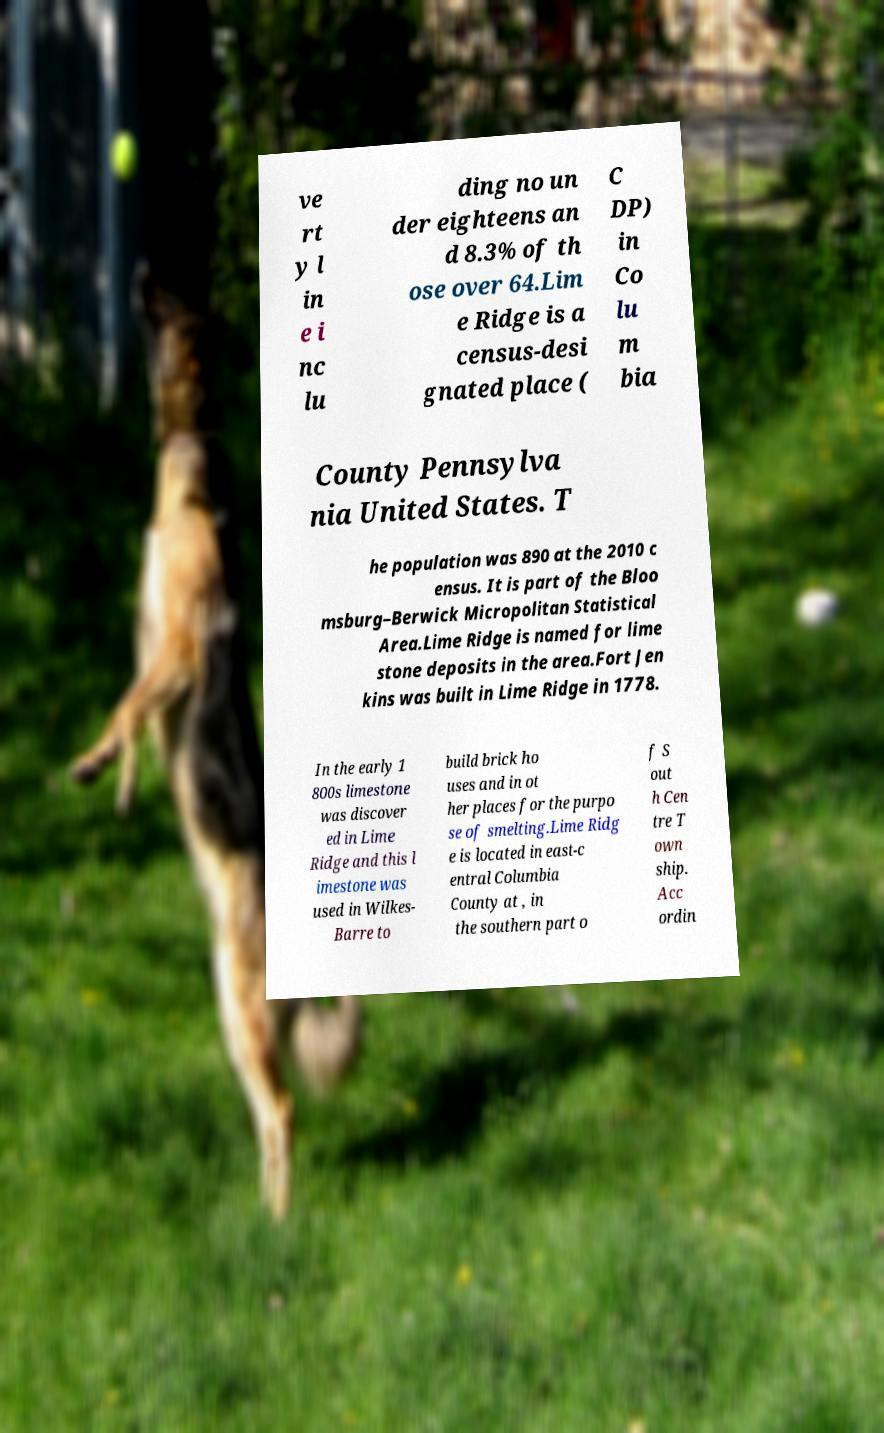Can you read and provide the text displayed in the image?This photo seems to have some interesting text. Can you extract and type it out for me? ve rt y l in e i nc lu ding no un der eighteens an d 8.3% of th ose over 64.Lim e Ridge is a census-desi gnated place ( C DP) in Co lu m bia County Pennsylva nia United States. T he population was 890 at the 2010 c ensus. It is part of the Bloo msburg–Berwick Micropolitan Statistical Area.Lime Ridge is named for lime stone deposits in the area.Fort Jen kins was built in Lime Ridge in 1778. In the early 1 800s limestone was discover ed in Lime Ridge and this l imestone was used in Wilkes- Barre to build brick ho uses and in ot her places for the purpo se of smelting.Lime Ridg e is located in east-c entral Columbia County at , in the southern part o f S out h Cen tre T own ship. Acc ordin 